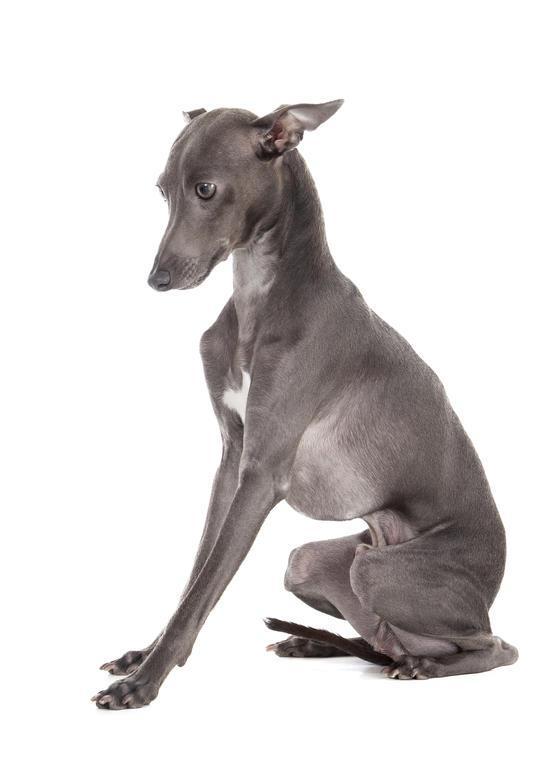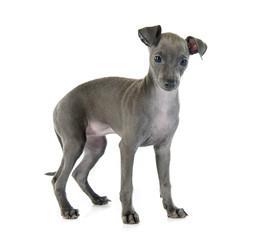The first image is the image on the left, the second image is the image on the right. Given the left and right images, does the statement "At least one of the dogs is wearing something on its feet." hold true? Answer yes or no. No. 